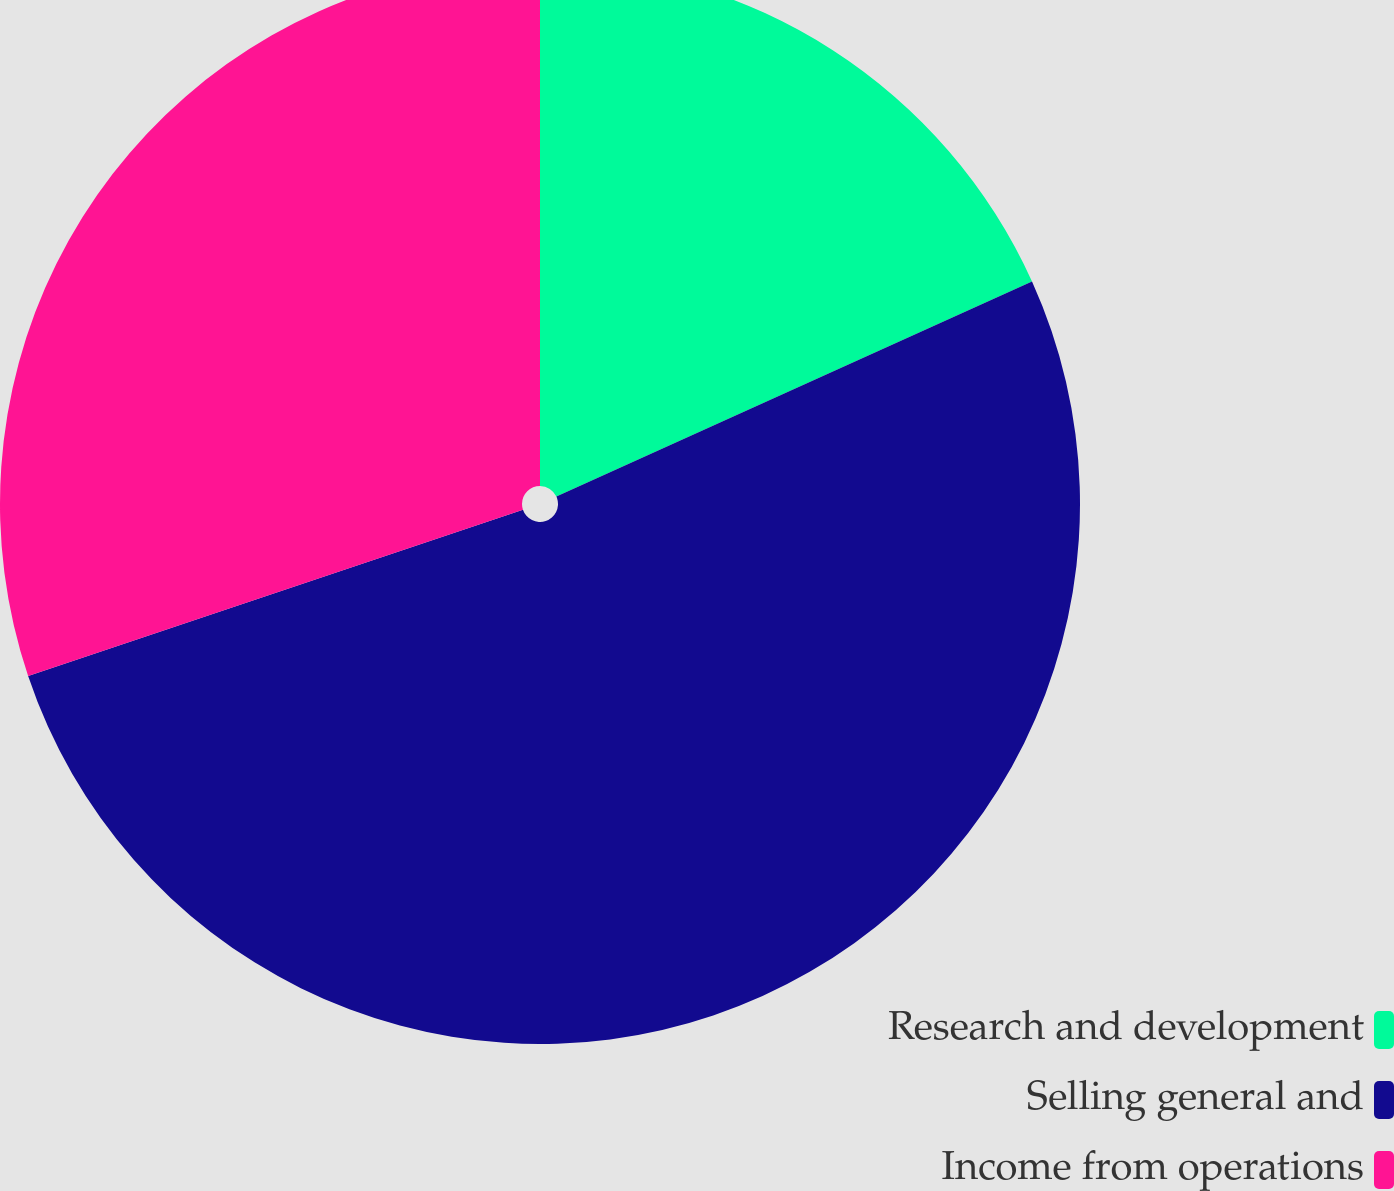<chart> <loc_0><loc_0><loc_500><loc_500><pie_chart><fcel>Research and development<fcel>Selling general and<fcel>Income from operations<nl><fcel>18.24%<fcel>51.6%<fcel>30.16%<nl></chart> 